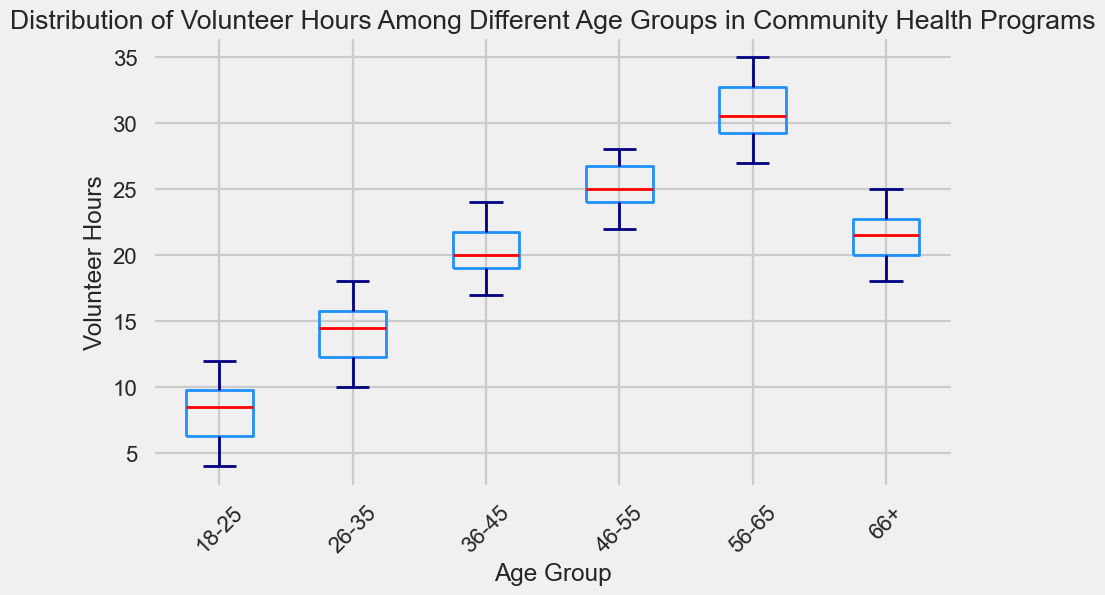What's the median volunteer hours for the 26-35 age group? To find the median, locate the middle value of the ordered volunteer hours. For the 26-35 age group, the data is [10, 11, 12, 13, 14, 15, 15, 16, 17, 18]. The median is the average of the 5th and 6th values, which are 14 and 15. So, (14 + 15) / 2 = 14.5.
Answer: 14.5 Which age group has the highest median volunteer hours? By inspecting the box plot, observe the position of the red line (median) within each box. The 56-65 age group has the highest median as its red line is the highest.
Answer: 56-65 What is the range of volunteer hours for the 18-25 age group? The range is calculated by subtracting the minimum value from the maximum value in the box plot. For 18-25, the whiskers represent the range, which spans from 4 to 12. Hence, 12 - 4 = 8.
Answer: 8 How does the interquartile range (IQR) of the 36-45 age group compare to that of the 46-55 age group? The IQR is the difference between the 75th percentile (top of the box) and the 25th percentile (bottom of the box). By visually comparing the heights of the boxes of 36-45 and 46-55, the IQR appears to be about the same for both groups (around 4-5 hours for both).
Answer: About the same Identify the age group with the most variation in volunteer hours. Variation can be assessed by looking at the length of the whiskers and the spread within the boxes. The 56-65 age group shows the most variation since its whiskers and box are the largest.
Answer: 56-65 What's the minimum volunteer hours recorded for the 66+ age group? The minimum value is represented by the lower whisker. For the 66+ age group, the lower whisker reaches down to 18.
Answer: 18 Which age group has the least spread in their volunteer hours? The least spread is indicated by the smallest box and shortest whiskers. The 18-25 age group has the least spread, as its box and whiskers are the shortest.
Answer: 18-25 What is the median volunteer hours of the 18-25 age group relative to the 36-45 age group? Compare the red lines of the two groups. The median for the 18-25 age group is much lower than that for the 36-45 age group, indicating fewer volunteer hours.
Answer: Lower 